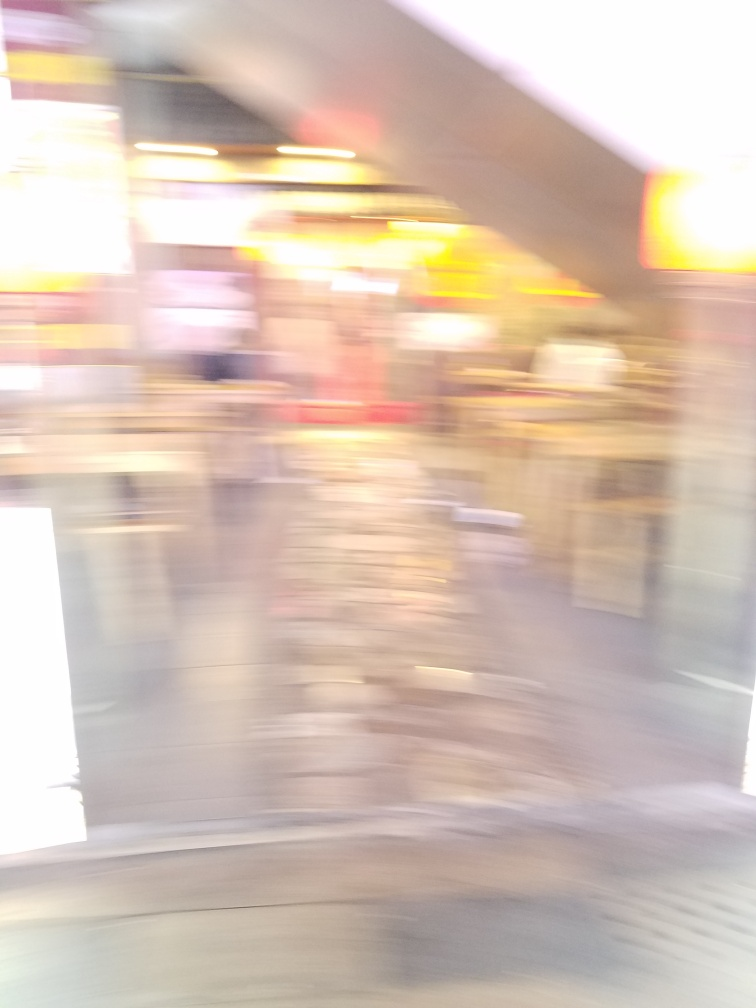Does the image suffer from underexposure?
A. Yes
B. No
Answer with the option's letter from the given choices directly. While the image does not exhibit typical characteristics of underexposure, such as an overall darkness or lack of visible details in the shadows, it is heavily blurred, which impairs clear visibility. This blurriness could be mistaken for underexposure by a quick glance. The response 'B' was chosen possibly because there appears to be sufficient light in the scene, but the quality issue here is motion blur rather than exposure. 